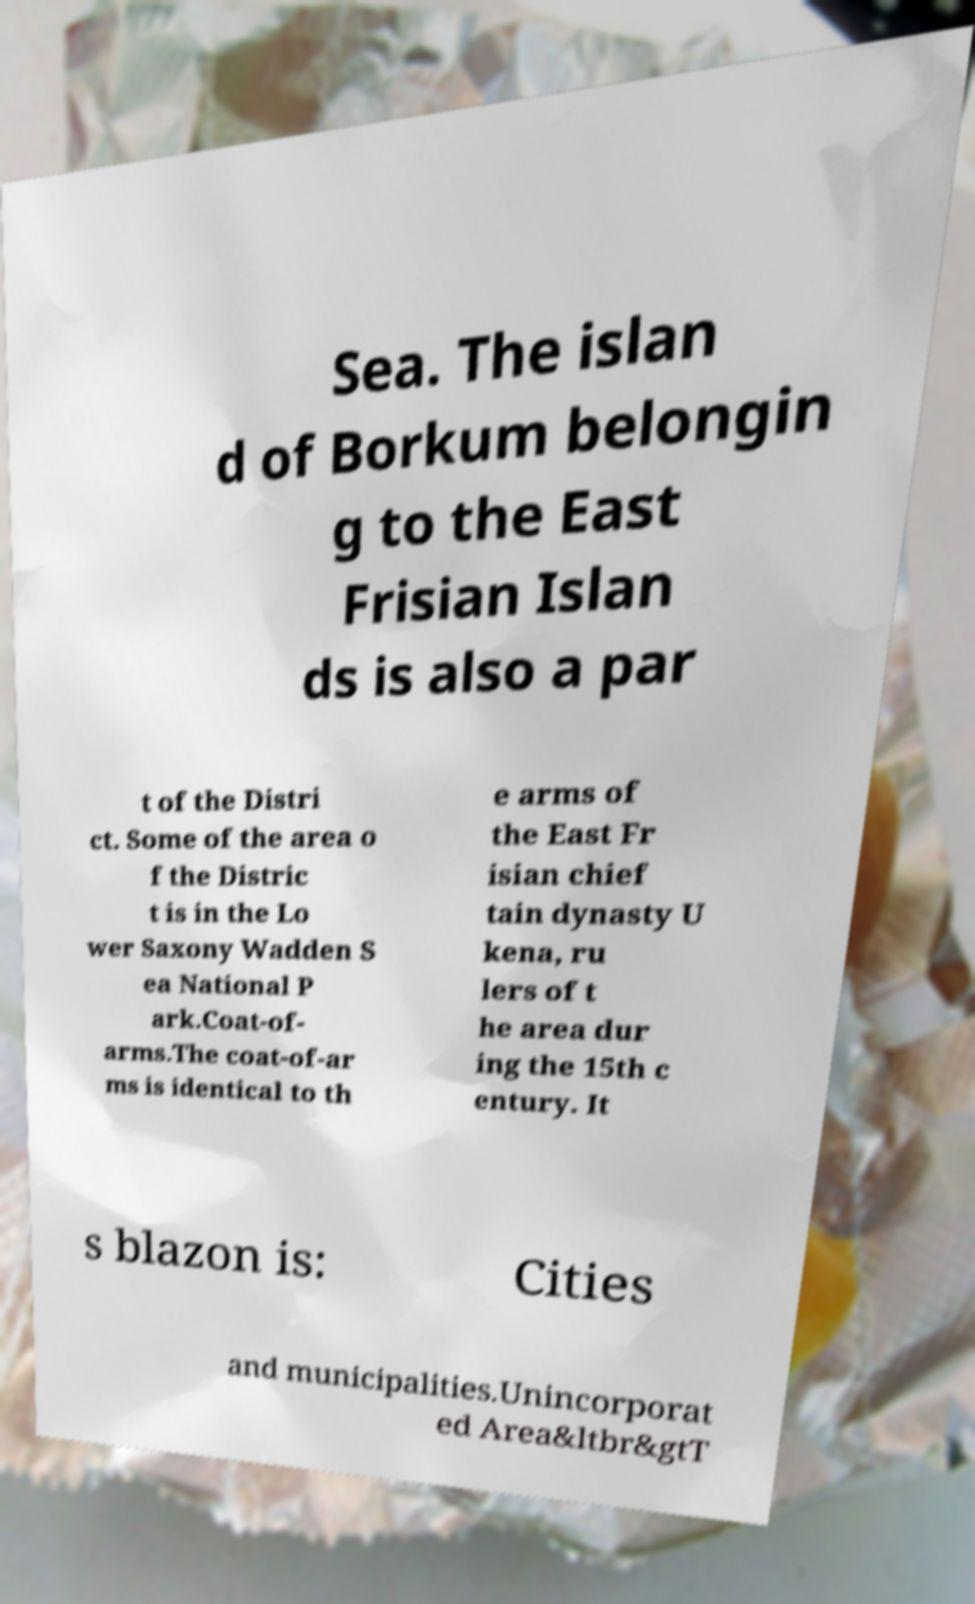Can you accurately transcribe the text from the provided image for me? Sea. The islan d of Borkum belongin g to the East Frisian Islan ds is also a par t of the Distri ct. Some of the area o f the Distric t is in the Lo wer Saxony Wadden S ea National P ark.Coat-of- arms.The coat-of-ar ms is identical to th e arms of the East Fr isian chief tain dynasty U kena, ru lers of t he area dur ing the 15th c entury. It s blazon is: Cities and municipalities.Unincorporat ed Area&ltbr&gtT 